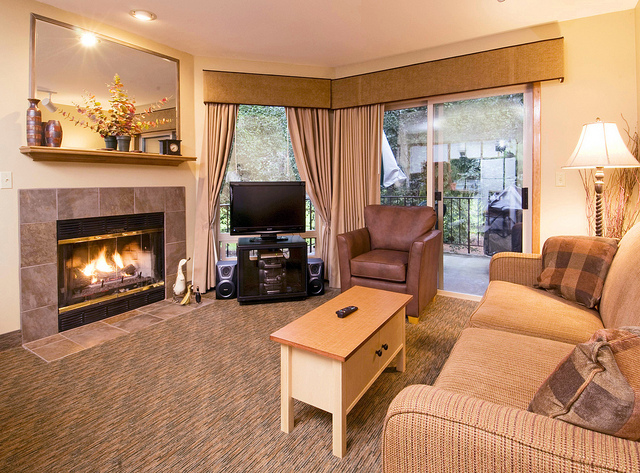<image>What color is the valance? I am not sure about the color of the valance. It could be pink, gold, beige, brown or tan. What color is the valance? I am not sure what color the valance is. It can be seen as pink, gold, beige, or brown. 